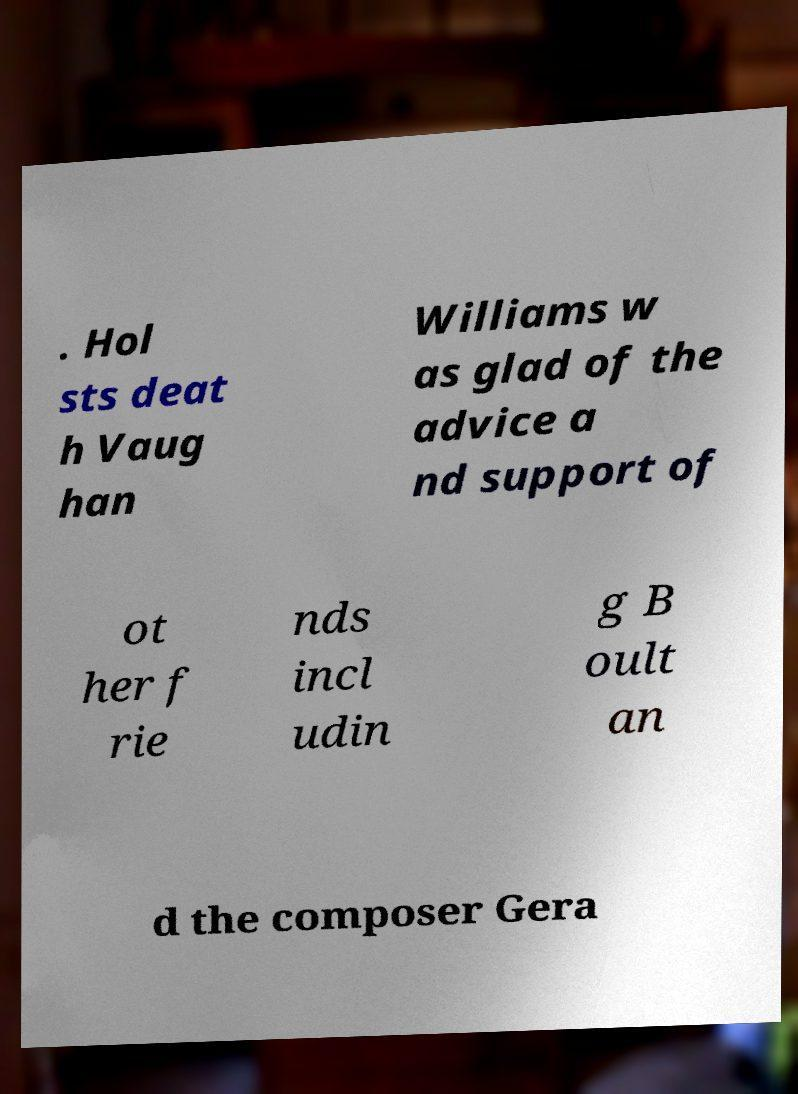What messages or text are displayed in this image? I need them in a readable, typed format. . Hol sts deat h Vaug han Williams w as glad of the advice a nd support of ot her f rie nds incl udin g B oult an d the composer Gera 